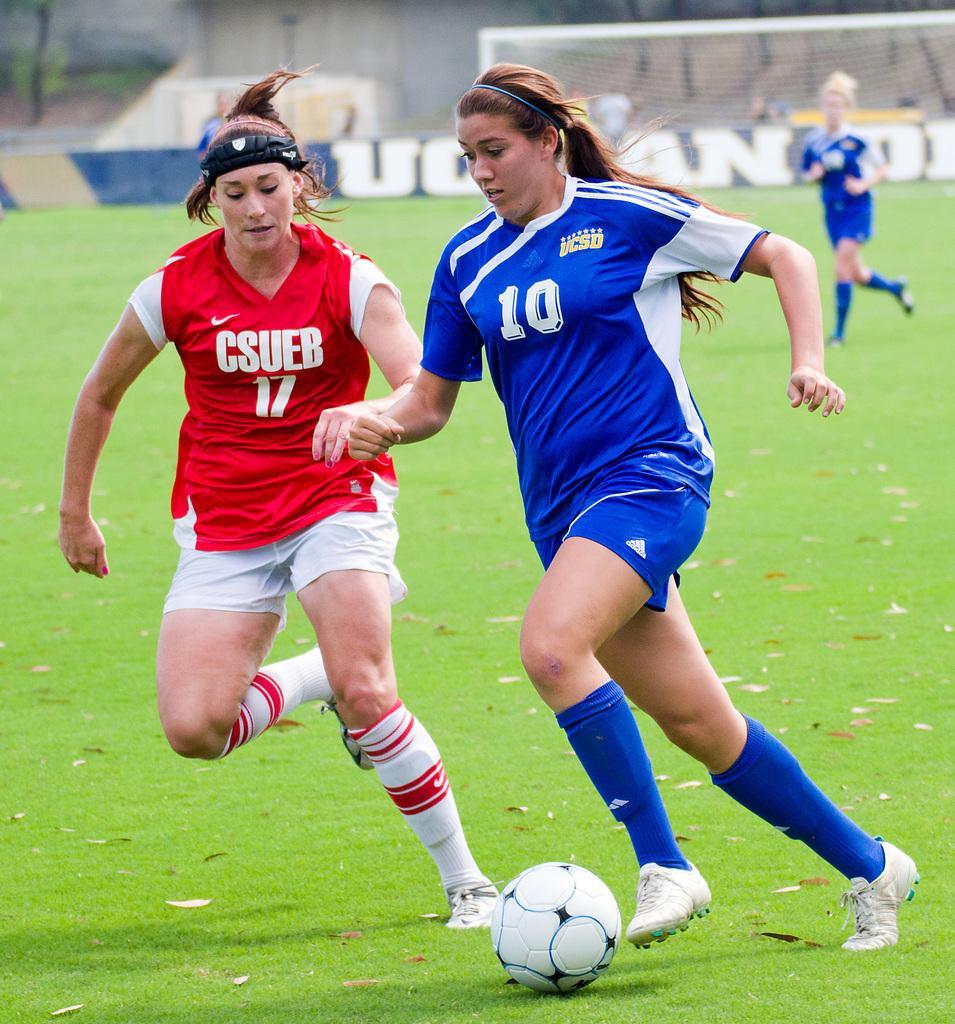Describe this image in one or two sentences. There are 2 women playing football. Behind them there is a woman,goal net and few people. 